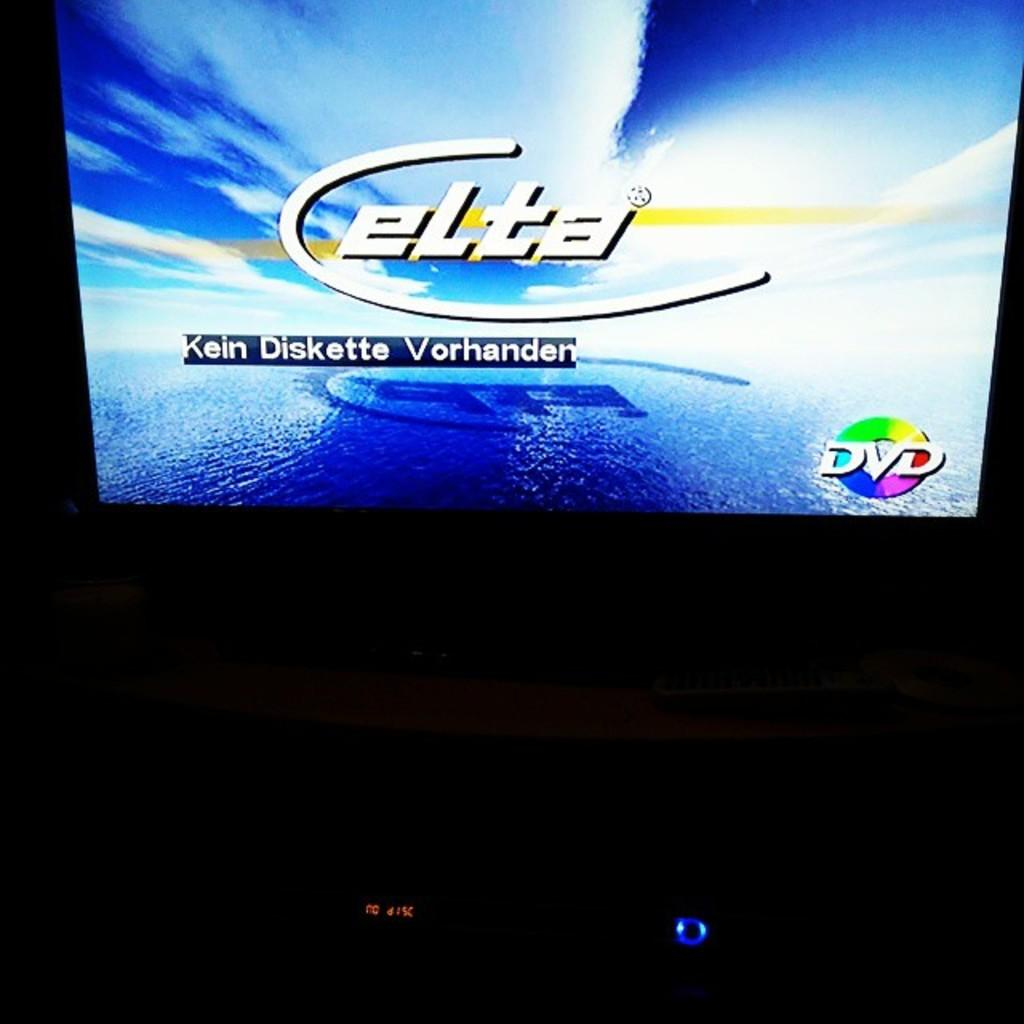<image>
Present a compact description of the photo's key features. Elta is displayed on the screen with DVD in the right corner. 